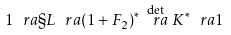<formula> <loc_0><loc_0><loc_500><loc_500>1 \ r a \S L \ r a ( 1 + F _ { 2 } ) ^ { * } \stackrel { \det } { \ r a } K ^ { * } \ r a 1</formula> 